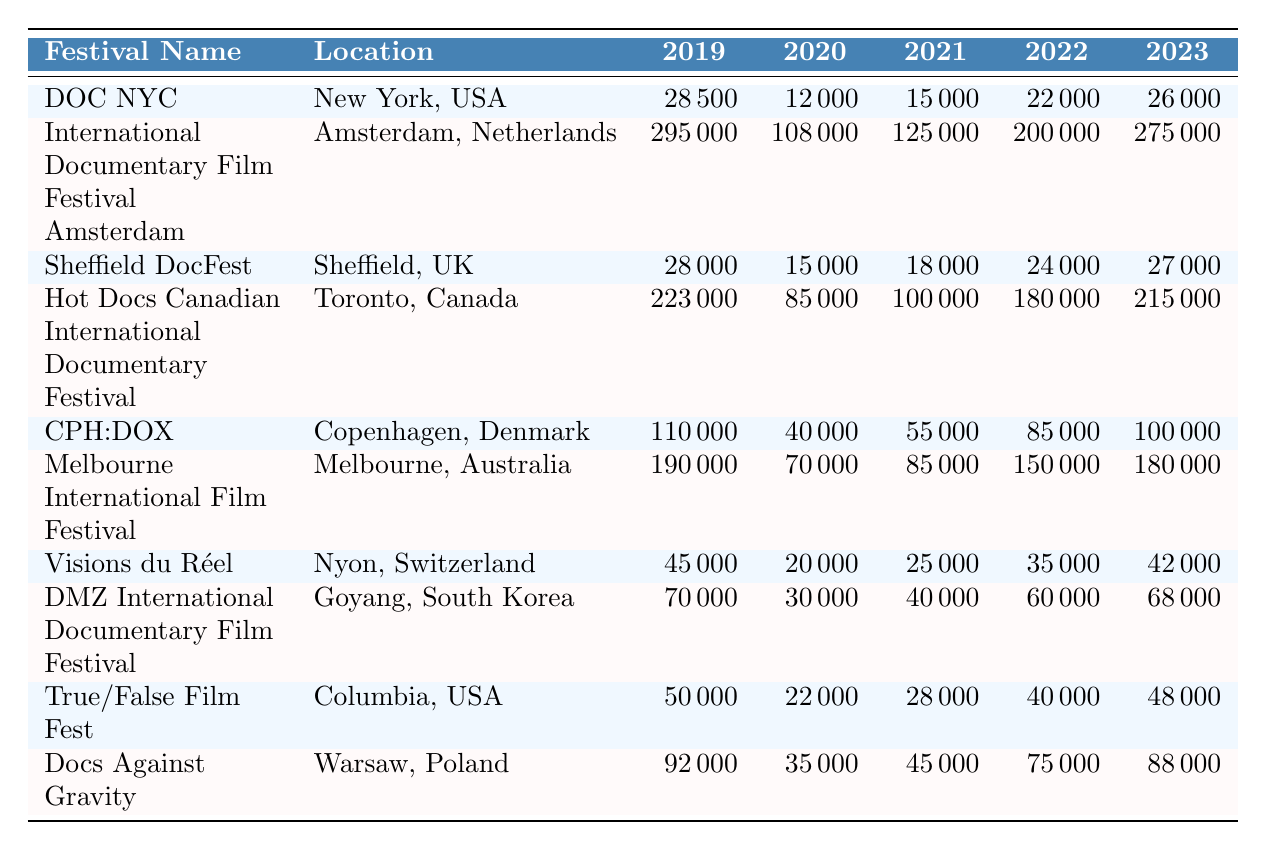What was the attendance at the International Documentary Film Festival Amsterdam in 2023? The table shows that the attendance for the International Documentary Film Festival Amsterdam in 2023 is recorded as 275,000.
Answer: 275000 Which festival had the highest attendance in 2019? By comparing the 2019 attendance figures for all festivals, the International Documentary Film Festival Amsterdam has the highest attendance with 295,000.
Answer: International Documentary Film Festival Amsterdam What is the difference in attendance for the Hot Docs Canadian International Documentary Festival between 2019 and 2023? The attendance in 2019 was 223,000 and in 2023 it was 215,000. The difference is calculated by subtracting 215,000 from 223,000, which equals 8,000.
Answer: 8000 Which two festivals saw the largest increase in attendance from 2021 to 2022? The increases from 2021 to 2022 for each festival are: Hot Docs (80,000 to 180,000 = 100,000 increase), Melbourne International Film Festival (85,000 to 150,000 = 65,000 increase), and DMZ International Documentary Film Festival (40,000 to 60,000 = 20,000 increase). Since Hot Docs has the highest increase, it is the largest, followed by Melbourne.
Answer: Hot Docs and Melbourne International Film Festival Did Sheffield DocFest have a higher attendance in 2022 or 2023? The table lists Sheffield DocFest with an attendance of 24,000 in 2022 and 27,000 in 2023. By comparing these figures, it is clear that attendance in 2023 is higher.
Answer: Yes What was the average attendance across all festivals in 2020? To find the average attendance for 2020, sum the attendance figures: 12,000 + 108,000 + 15,000 + 85,000 + 40,000 + 70,000 + 20,000 + 30,000 + 22,000 + 35,000 = 420,000. There are 10 festivals, so divide 420,000 by 10, resulting in an average of 42,000.
Answer: 42000 Which festival’s attendance in 2021 was closest to the median attendance of all festivals for that year? The attendance figures for 2021 are: 15,000 (DOC NYC), 125,000 (International Documentary Film Festival Amsterdam), 18,000 (Sheffield DocFest), 100,000 (Hot Docs), 55,000 (CPH:DOX), 85,000 (Melbourne), 25,000 (Visions du Réel), 40,000 (DMZ), 28,000 (True/False), and 45,000 (Docs Against Gravity). The median attendance is 55,000, and the closest figure is 55,000 for CPH:DOX.
Answer: CPH:DOX What is the trend in attendance for Visions du Réel from 2019 to 2023? The attendance for Visions du Réel over the years is: 45,000 in 2019, 20,000 in 2020, 25,000 in 2021, 35,000 in 2022, and 42,000 in 2023. The trend shows an increase from 2020 to 2023 after a drop in 2020.
Answer: Increased since 2020 Which festival has the smallest attendance in 2021? By inspecting the attendance for 2021, the smallest value is 15,000 from DOC NYC.
Answer: DOC NYC What percentage of attendance did the DMZ International Documentary Film Festival achieve in 2023 compared to its 2019 attendance? DMZ's attendance in 2019 was 70,000 and in 2023 it was 68,000. To find the percentage, use the formula: (68,000 / 70,000) * 100 = 97.14%.
Answer: 97.14% 